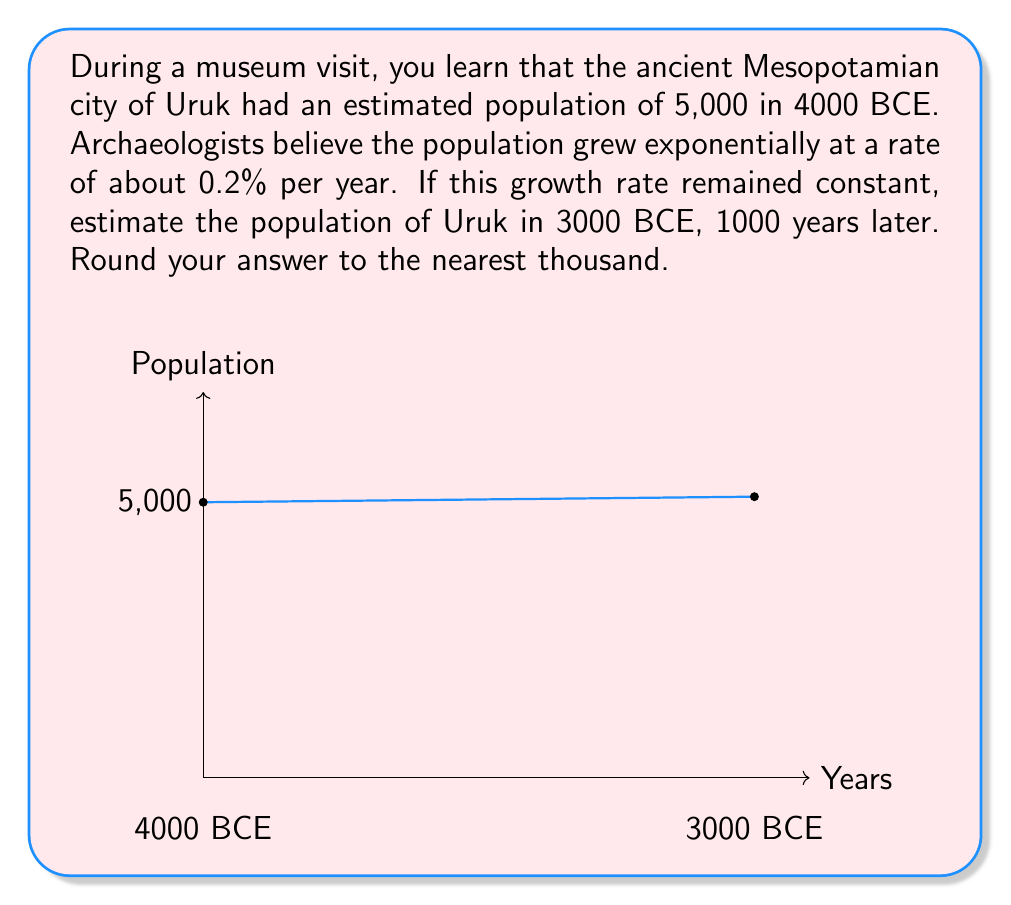What is the answer to this math problem? To solve this problem, we'll use the exponential growth model:

$$P(t) = P_0 \cdot e^{rt}$$

Where:
$P(t)$ is the population at time $t$
$P_0$ is the initial population
$r$ is the growth rate (as a decimal)
$t$ is the time in years

Given:
$P_0 = 5,000$ (initial population in 4000 BCE)
$r = 0.002$ (0.2% per year expressed as a decimal)
$t = 1000$ years

Step 1: Plug the values into the exponential growth formula:
$$P(1000) = 5000 \cdot e^{0.002 \cdot 1000}$$

Step 2: Simplify the exponent:
$$P(1000) = 5000 \cdot e^2$$

Step 3: Calculate $e^2$ (you can use a calculator for this):
$$P(1000) = 5000 \cdot 7.389056$$

Step 4: Multiply:
$$P(1000) = 36,945.28$$

Step 5: Round to the nearest thousand:
$$P(1000) \approx 37,000$$

Therefore, the estimated population of Uruk in 3000 BCE would be approximately 37,000 people.
Answer: 37,000 people 